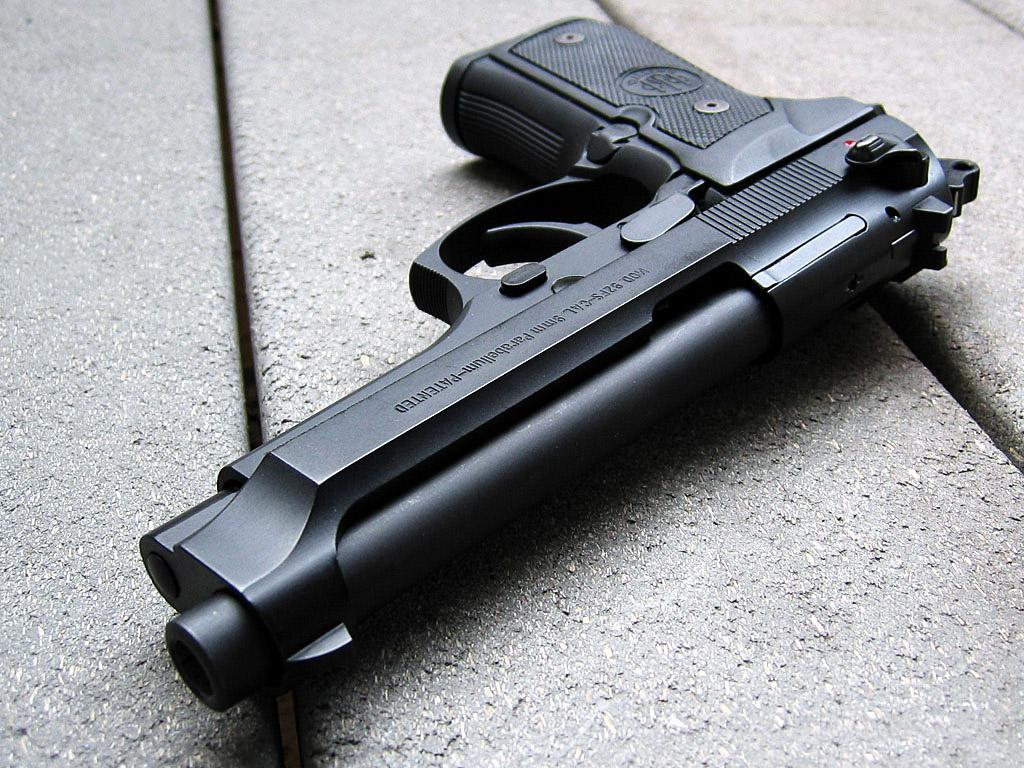What object is present in the image? There is a gun in the image. Where is the gun located? The gun is on a surface. How many nuts can be seen on the mountain in the image? There is no mountain or nuts present in the image; it only features a gun on a surface. 